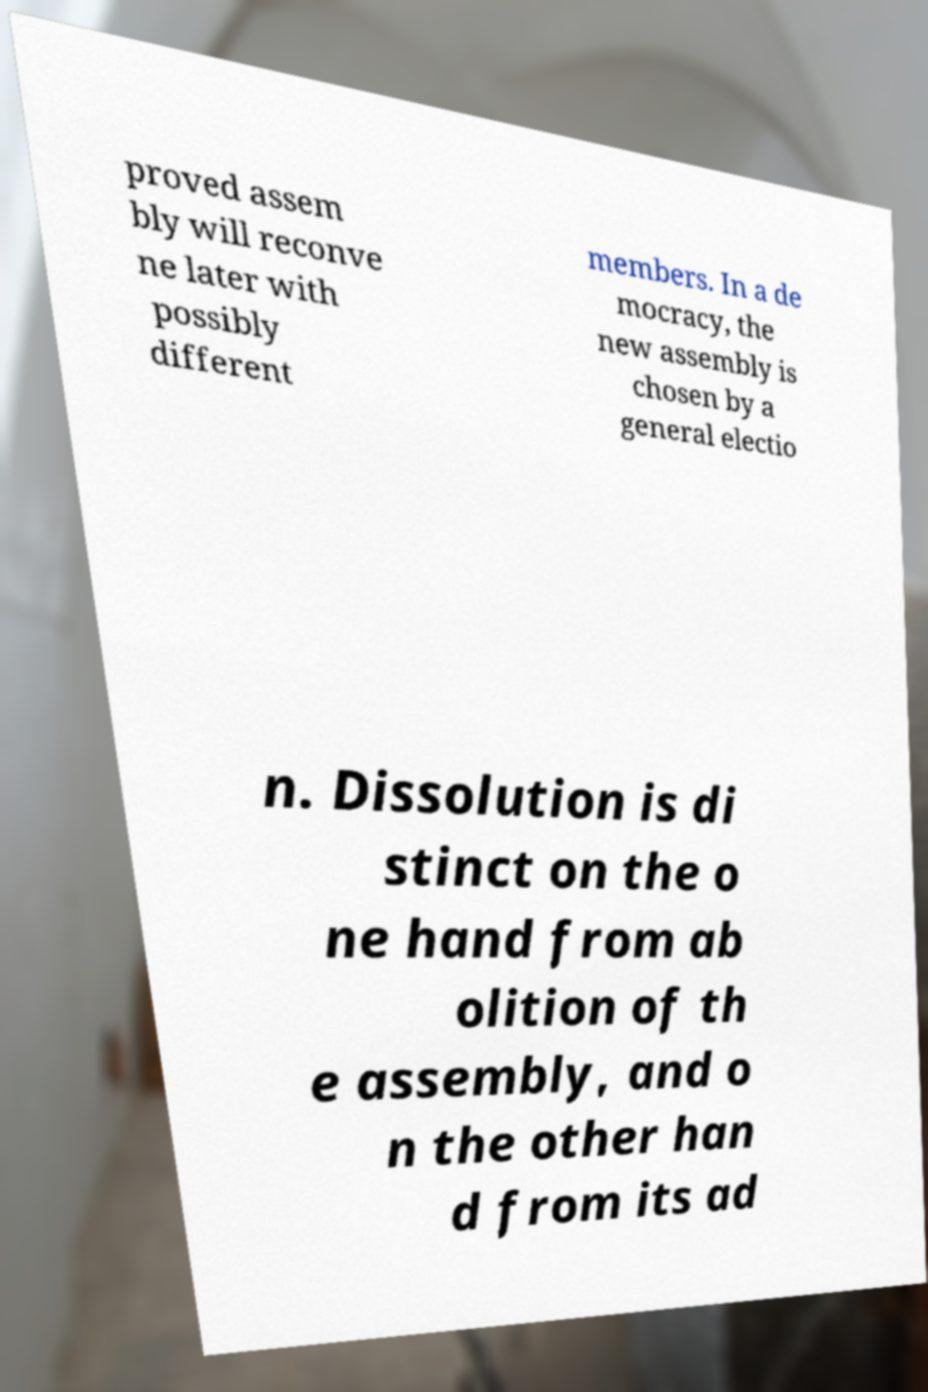Can you read and provide the text displayed in the image?This photo seems to have some interesting text. Can you extract and type it out for me? proved assem bly will reconve ne later with possibly different members. In a de mocracy, the new assembly is chosen by a general electio n. Dissolution is di stinct on the o ne hand from ab olition of th e assembly, and o n the other han d from its ad 